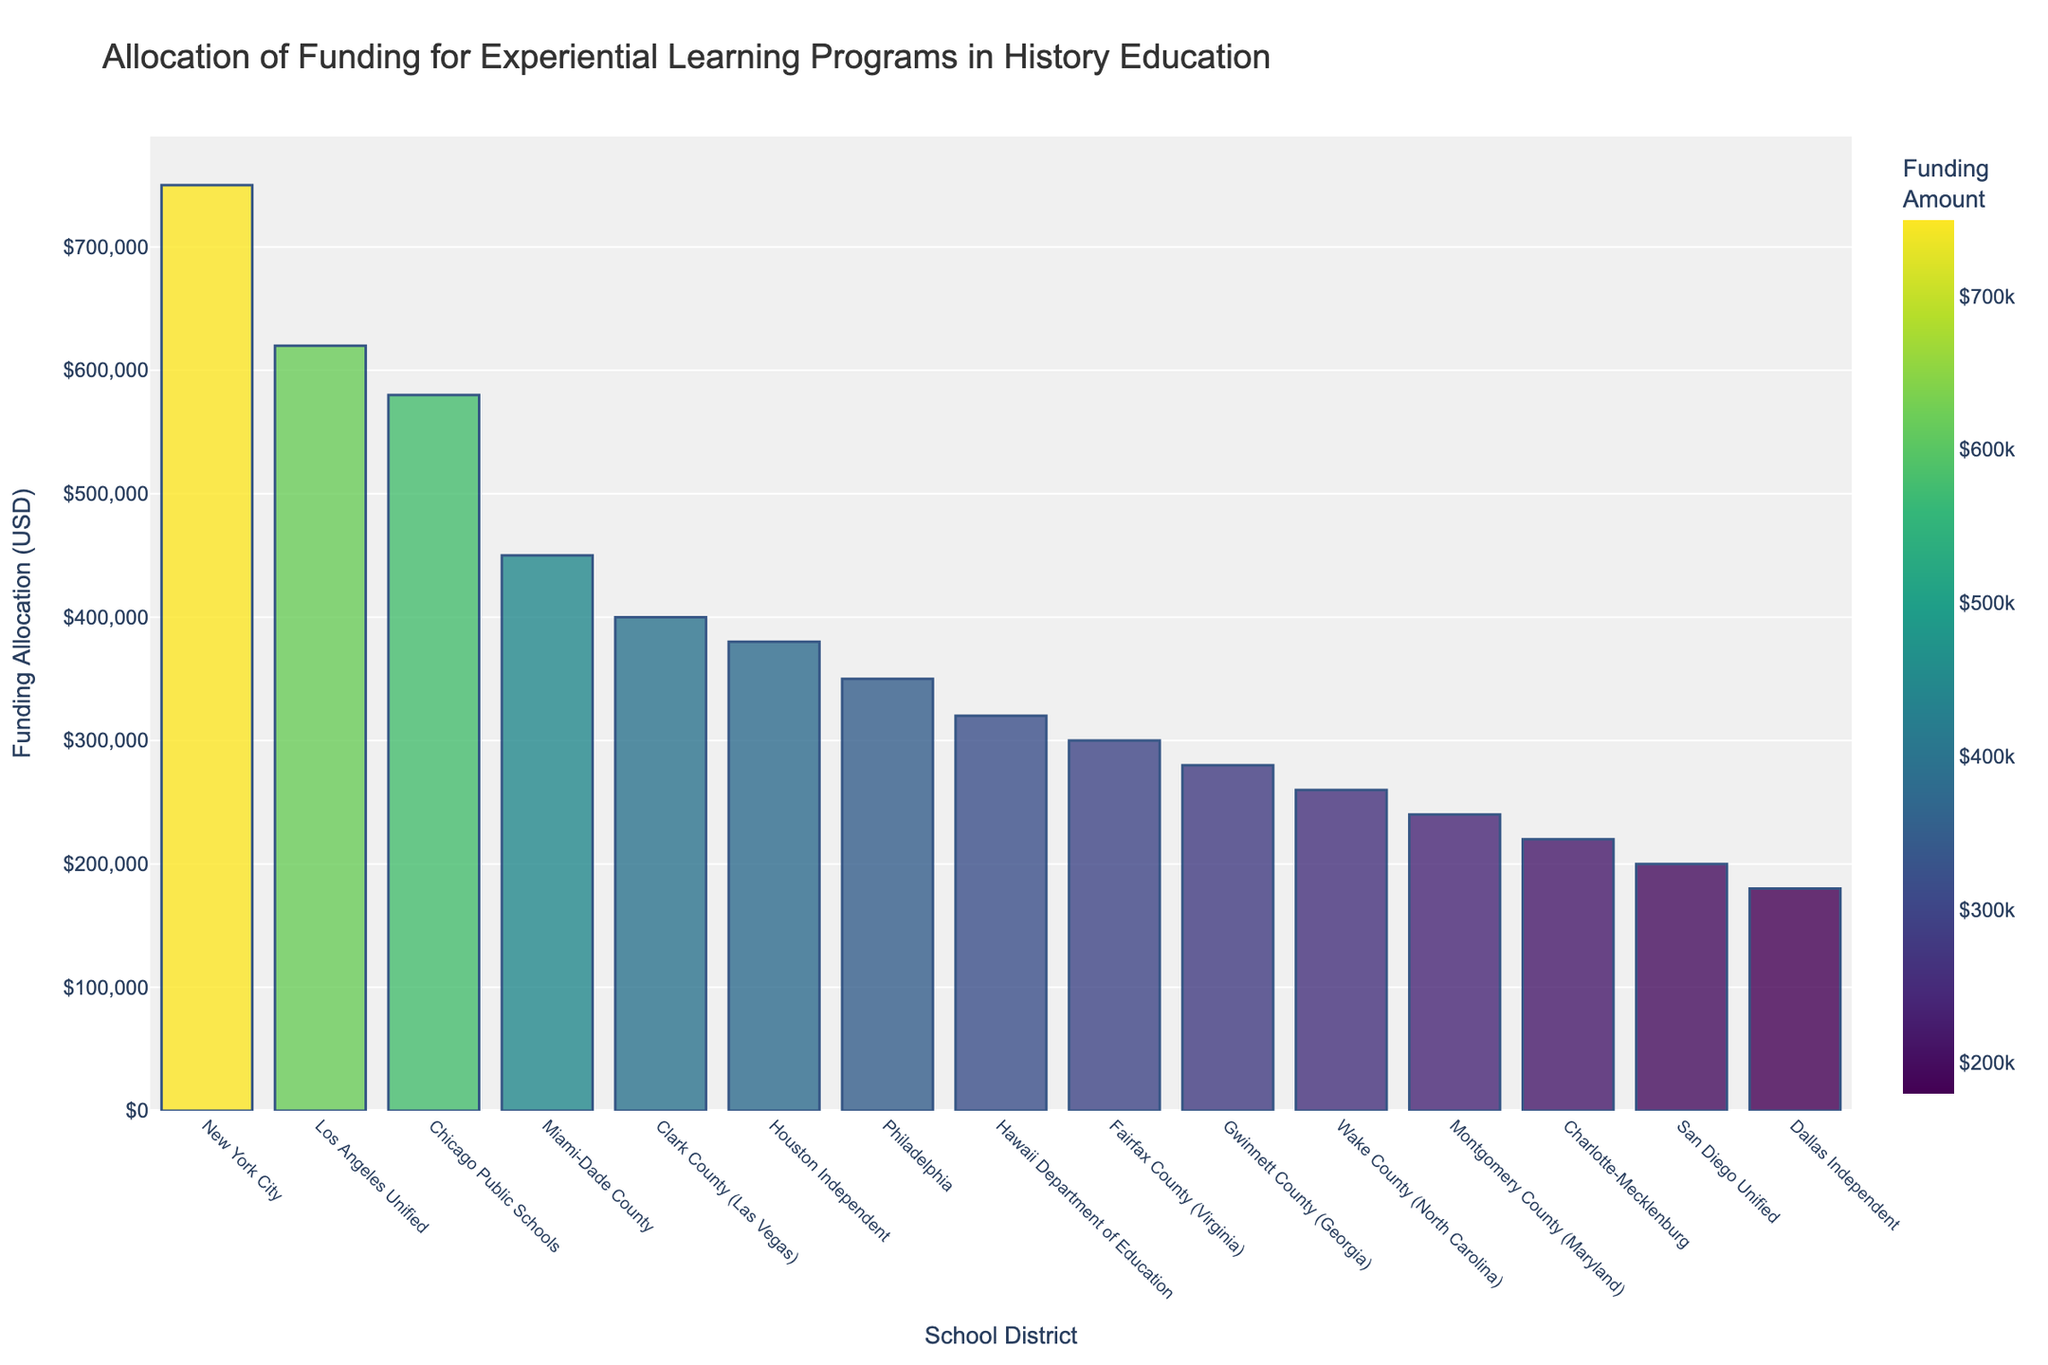Which school district has the highest funding allocation for experiential learning programs in history education? The bar for New York City is the tallest and represents the highest funding allocation.
Answer: New York City What is the total funding allocation for Houston Independent and Philadelphia combined? Houston Independent has $380,000 in funding and Philadelphia has $350,000. Combining these amounts gives $380,000 + $350,000 = $730,000.
Answer: $730,000 Which school districts have funding allocations less than $300,000? By inspecting the lengths of the bars, the school districts with funding allocations less than $300,000 are Hawaii Department of Education, Fairfax County (Virginia), 
Gwinnett County (Georgia), Wake County (North Carolina), Montgomery County (Maryland), Charlotte-Mecklenburg, San Diego Unified, and Dallas Independent.
Answer: Hawaii Department of Education, Fairfax County (Virginia), Gwinnett County (Georgia), Wake County (North Carolina), Montgomery County (Maryland), Charlotte-Mecklenburg, San Diego Unified, Dallas Independent How much more funding does Los Angeles Unified receive for experiential learning compared to Clark County (Las Vegas)? Los Angeles Unified receives $620,000 and Clark County receives $400,000. The difference in funding allocation is $620,000 - $400,000 = $220,000.
Answer: $220,000 Which school district has the lowest funding allocation, and how much is it? The shortest bar corresponds to Dallas Independent, with the lowest funding allocation of $180,000.
Answer: Dallas Independent, $180,000 What is the average funding allocation for the given school districts? Adding up all the funding allocations: $750,000 + $620,000 + $580,000 + $450,000 + $400,000 + $380,000 + $350,000 + $320,000 + $300,000 + $280,000 + $260,000 + $240,000 + $220,000 + $200,000 + $180,000 = $5,530,000. There are 15 school districts, so the average is $5,530,000 / 15 = $368,666.67.
Answer: $368,666.67 Which two school districts have a funding allocation difference of exactly $100,000, and what are their allocations? Inspect the bars to find New York City ($750,000) and Chicago Public Schools ($580,000), which have a difference of $750,000 - $580,000 = $170,000. Continue with other pairs: Los Angeles Unified ($620,000) and Miami-Dade County ($450,000) have a difference of $170,000. Another valid pair is Philadelphia ($350,000) and Hawaii Department of Education ($320,000) which have a difference of $30,000. In this dataset, no pairs have a difference of exactly $100,000.
Answer: None What is the sum of funding allocations for the three districts with the highest allocations? The three districts with the highest funding allocations are New York City ($750,000), Los Angeles Unified ($620,000), and Chicago Public Schools ($580,000). The sum is $750,000 + $620,000 + $580,000 = $1,950,000.
Answer: $1,950,000 How does the funding allocation of Wake County (North Carolina) compare to Montgomery County (Maryland)? The bar showing the funding for Wake County (North Carolina) is longer than that for Montgomery County (Maryland). Wake County has $260,000, while Montgomery County has $240,000.
Answer: Wake County (North Carolina) has $20,000 more 